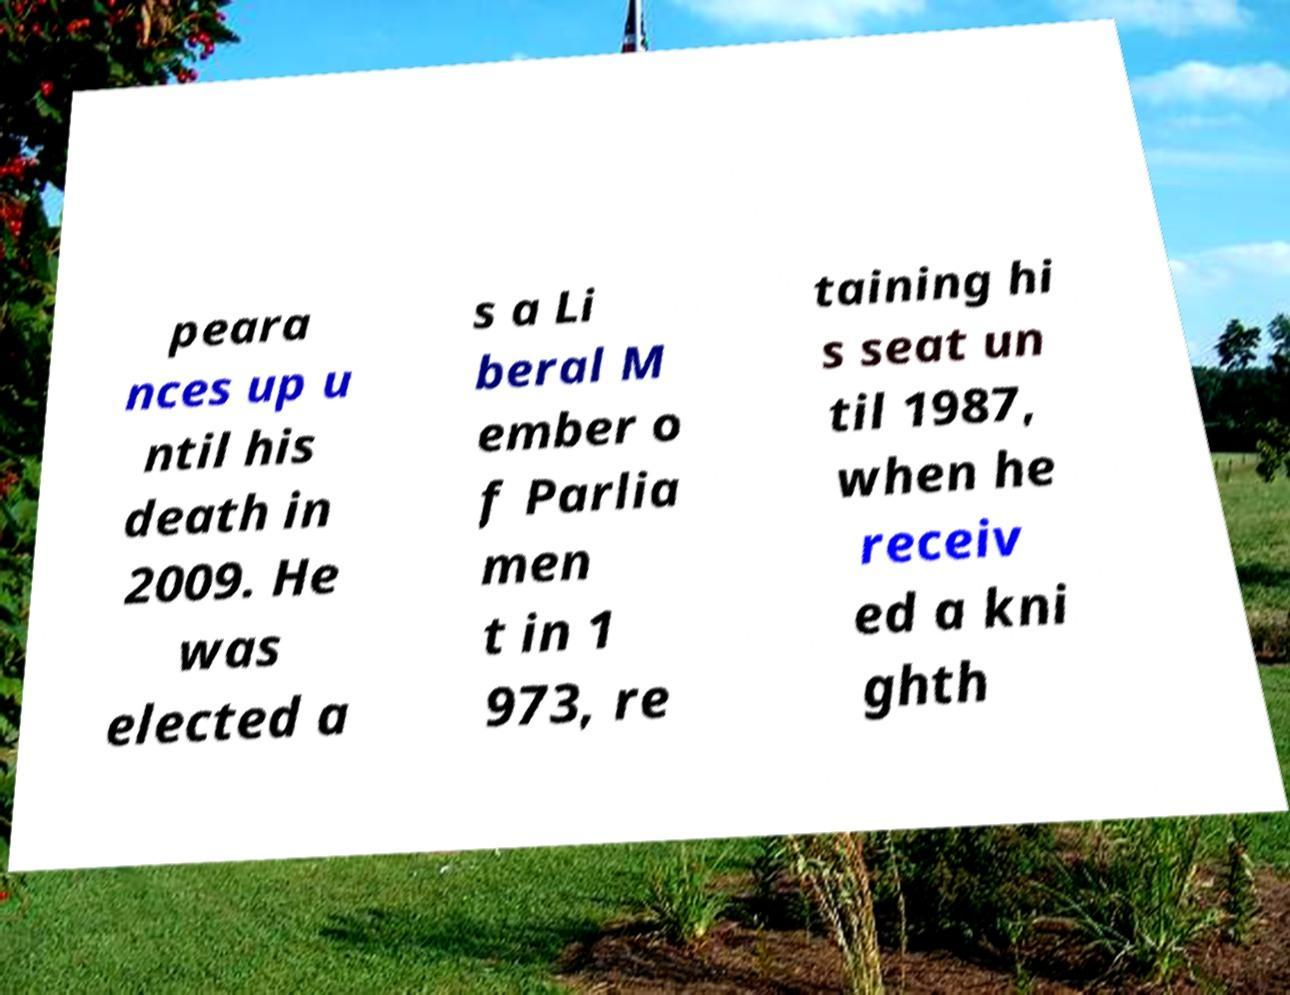Can you accurately transcribe the text from the provided image for me? peara nces up u ntil his death in 2009. He was elected a s a Li beral M ember o f Parlia men t in 1 973, re taining hi s seat un til 1987, when he receiv ed a kni ghth 